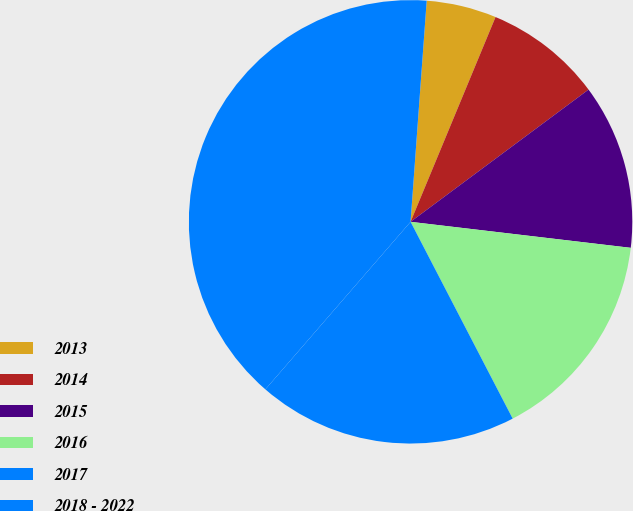Convert chart to OTSL. <chart><loc_0><loc_0><loc_500><loc_500><pie_chart><fcel>2013<fcel>2014<fcel>2015<fcel>2016<fcel>2017<fcel>2018 - 2022<nl><fcel>5.1%<fcel>8.57%<fcel>12.04%<fcel>15.51%<fcel>18.98%<fcel>39.79%<nl></chart> 